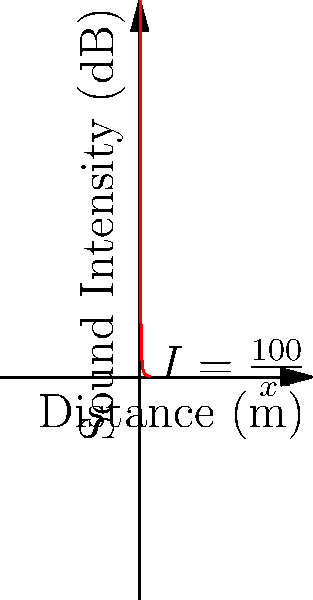As a viola player, you're interested in understanding how sound intensity changes with distance. The graph shows the relationship between sound intensity (I) in decibels and distance (x) in meters from a viola, described by the function $I(x) = \frac{100}{x^2}$. At what rate is the sound intensity changing when the listener is 5 meters away from the viola? To find the rate of change of sound intensity with respect to distance at 5 meters, we need to follow these steps:

1) The function given is $I(x) = \frac{100}{x^2}$

2) To find the rate of change, we need to differentiate this function with respect to x:
   
   $\frac{dI}{dx} = \frac{d}{dx}(\frac{100}{x^2})$

3) Using the power rule of differentiation:
   
   $\frac{dI}{dx} = 100 \cdot (-2x^{-3}) = -\frac{200}{x^3}$

4) Now, we need to evaluate this at x = 5:
   
   $\frac{dI}{dx}\Big|_{x=5} = -\frac{200}{5^3} = -\frac{200}{125} = -1.6$

5) Therefore, at 5 meters, the rate of change of sound intensity with respect to distance is -1.6 dB/m.

The negative sign indicates that the sound intensity is decreasing as the distance increases.
Answer: $-1.6$ dB/m 